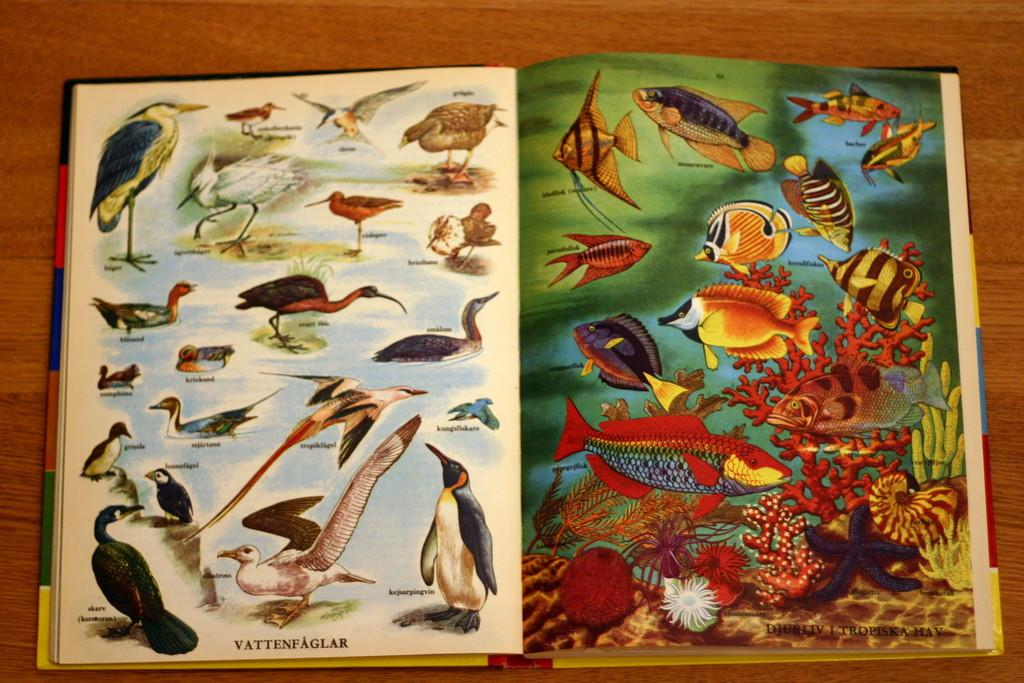What is the main subject of the book in the image? The book contains pictures of water animals and birds. What types of animals can be seen in the book? The book contains pictures of water animals and birds. What is the reaction of the river to the book in the image? There is no river present in the image, so it cannot react to the book. 